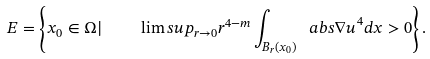<formula> <loc_0><loc_0><loc_500><loc_500>E = \left \{ x _ { 0 } \in \Omega | \quad \lim s u p _ { r \to 0 } r ^ { 4 - m } \int _ { B _ { r } ( x _ { 0 } ) } \ a b s { \nabla u } ^ { 4 } d x > 0 \right \} .</formula> 